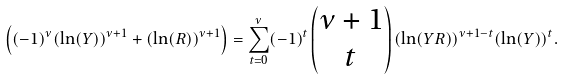<formula> <loc_0><loc_0><loc_500><loc_500>\left ( ( - 1 ) ^ { \nu } ( \ln ( Y ) ) ^ { \nu + 1 } + ( \ln ( R ) ) ^ { \nu + 1 } \right ) = \sum _ { t = 0 } ^ { \nu } ( - 1 ) ^ { t } \begin{pmatrix} \nu + 1 \\ t \end{pmatrix} ( \ln ( Y R ) ) ^ { \nu + 1 - t } ( \ln ( Y ) ) ^ { t } .</formula> 